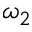<formula> <loc_0><loc_0><loc_500><loc_500>\omega _ { 2 }</formula> 